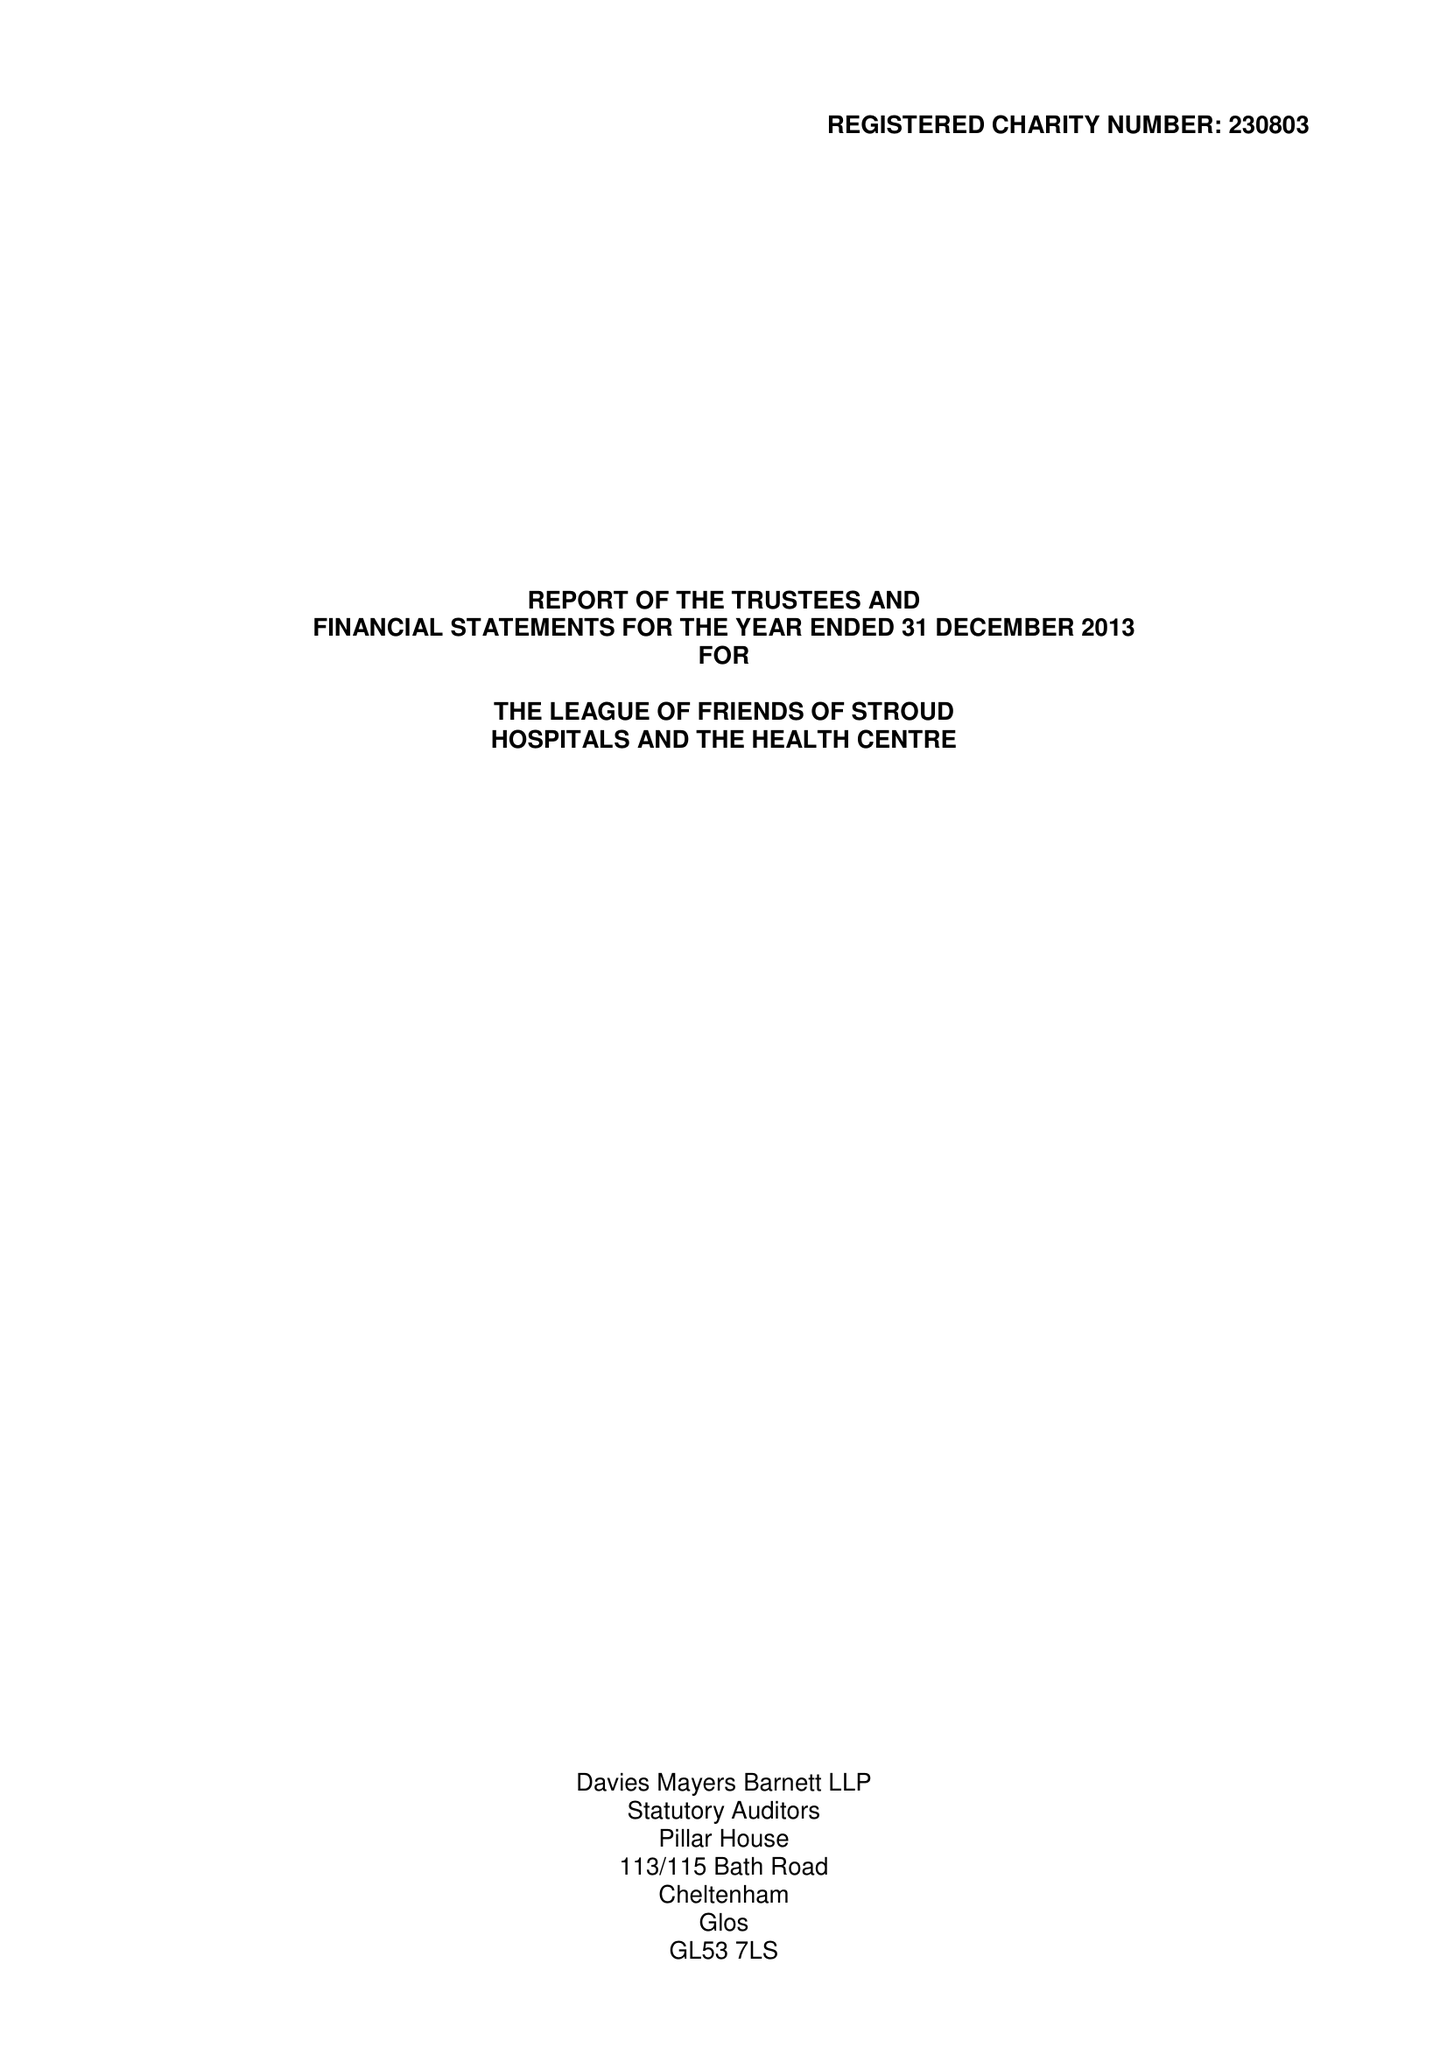What is the value for the address__postcode?
Answer the question using a single word or phrase. GL5 2HY 